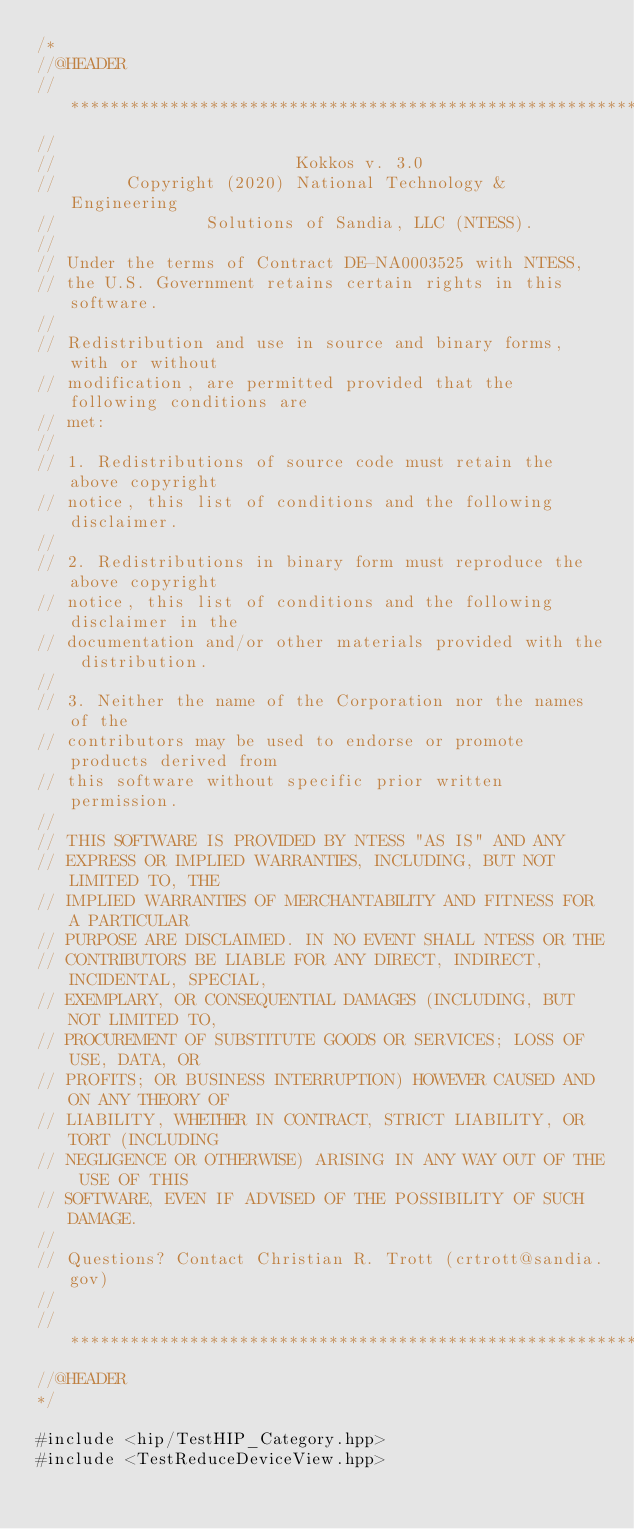Convert code to text. <code><loc_0><loc_0><loc_500><loc_500><_C++_>/*
//@HEADER
// ************************************************************************
//
//                        Kokkos v. 3.0
//       Copyright (2020) National Technology & Engineering
//               Solutions of Sandia, LLC (NTESS).
//
// Under the terms of Contract DE-NA0003525 with NTESS,
// the U.S. Government retains certain rights in this software.
//
// Redistribution and use in source and binary forms, with or without
// modification, are permitted provided that the following conditions are
// met:
//
// 1. Redistributions of source code must retain the above copyright
// notice, this list of conditions and the following disclaimer.
//
// 2. Redistributions in binary form must reproduce the above copyright
// notice, this list of conditions and the following disclaimer in the
// documentation and/or other materials provided with the distribution.
//
// 3. Neither the name of the Corporation nor the names of the
// contributors may be used to endorse or promote products derived from
// this software without specific prior written permission.
//
// THIS SOFTWARE IS PROVIDED BY NTESS "AS IS" AND ANY
// EXPRESS OR IMPLIED WARRANTIES, INCLUDING, BUT NOT LIMITED TO, THE
// IMPLIED WARRANTIES OF MERCHANTABILITY AND FITNESS FOR A PARTICULAR
// PURPOSE ARE DISCLAIMED. IN NO EVENT SHALL NTESS OR THE
// CONTRIBUTORS BE LIABLE FOR ANY DIRECT, INDIRECT, INCIDENTAL, SPECIAL,
// EXEMPLARY, OR CONSEQUENTIAL DAMAGES (INCLUDING, BUT NOT LIMITED TO,
// PROCUREMENT OF SUBSTITUTE GOODS OR SERVICES; LOSS OF USE, DATA, OR
// PROFITS; OR BUSINESS INTERRUPTION) HOWEVER CAUSED AND ON ANY THEORY OF
// LIABILITY, WHETHER IN CONTRACT, STRICT LIABILITY, OR TORT (INCLUDING
// NEGLIGENCE OR OTHERWISE) ARISING IN ANY WAY OUT OF THE USE OF THIS
// SOFTWARE, EVEN IF ADVISED OF THE POSSIBILITY OF SUCH DAMAGE.
//
// Questions? Contact Christian R. Trott (crtrott@sandia.gov)
//
// ************************************************************************
//@HEADER
*/

#include <hip/TestHIP_Category.hpp>
#include <TestReduceDeviceView.hpp>
</code> 